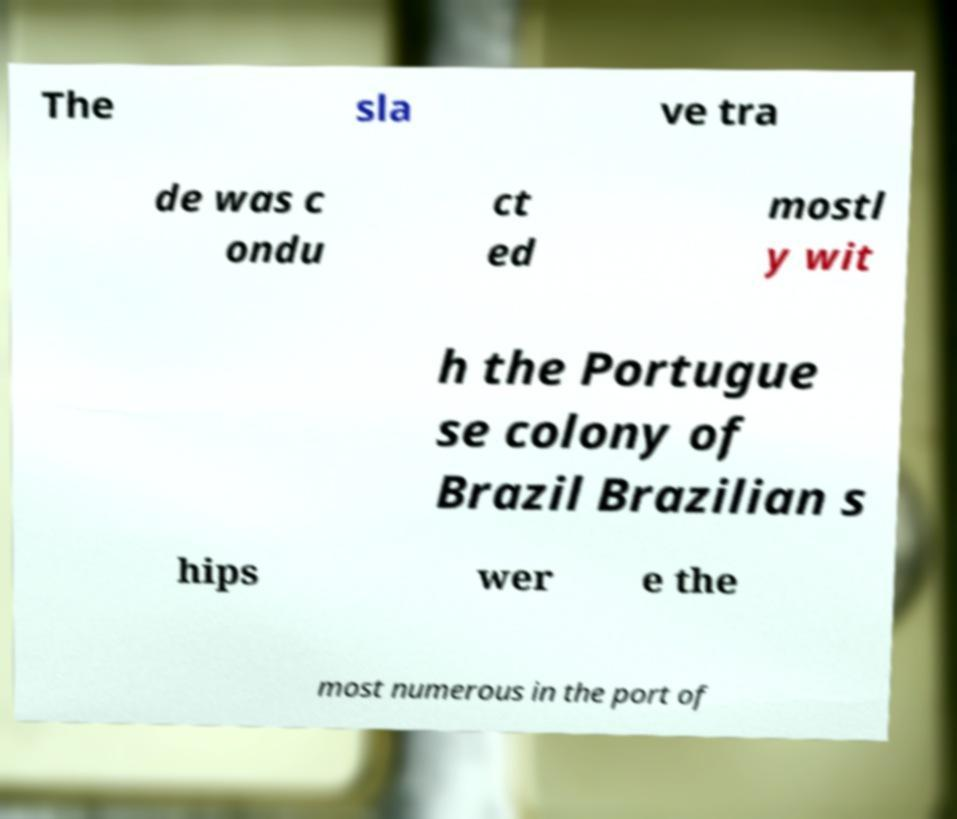For documentation purposes, I need the text within this image transcribed. Could you provide that? The sla ve tra de was c ondu ct ed mostl y wit h the Portugue se colony of Brazil Brazilian s hips wer e the most numerous in the port of 